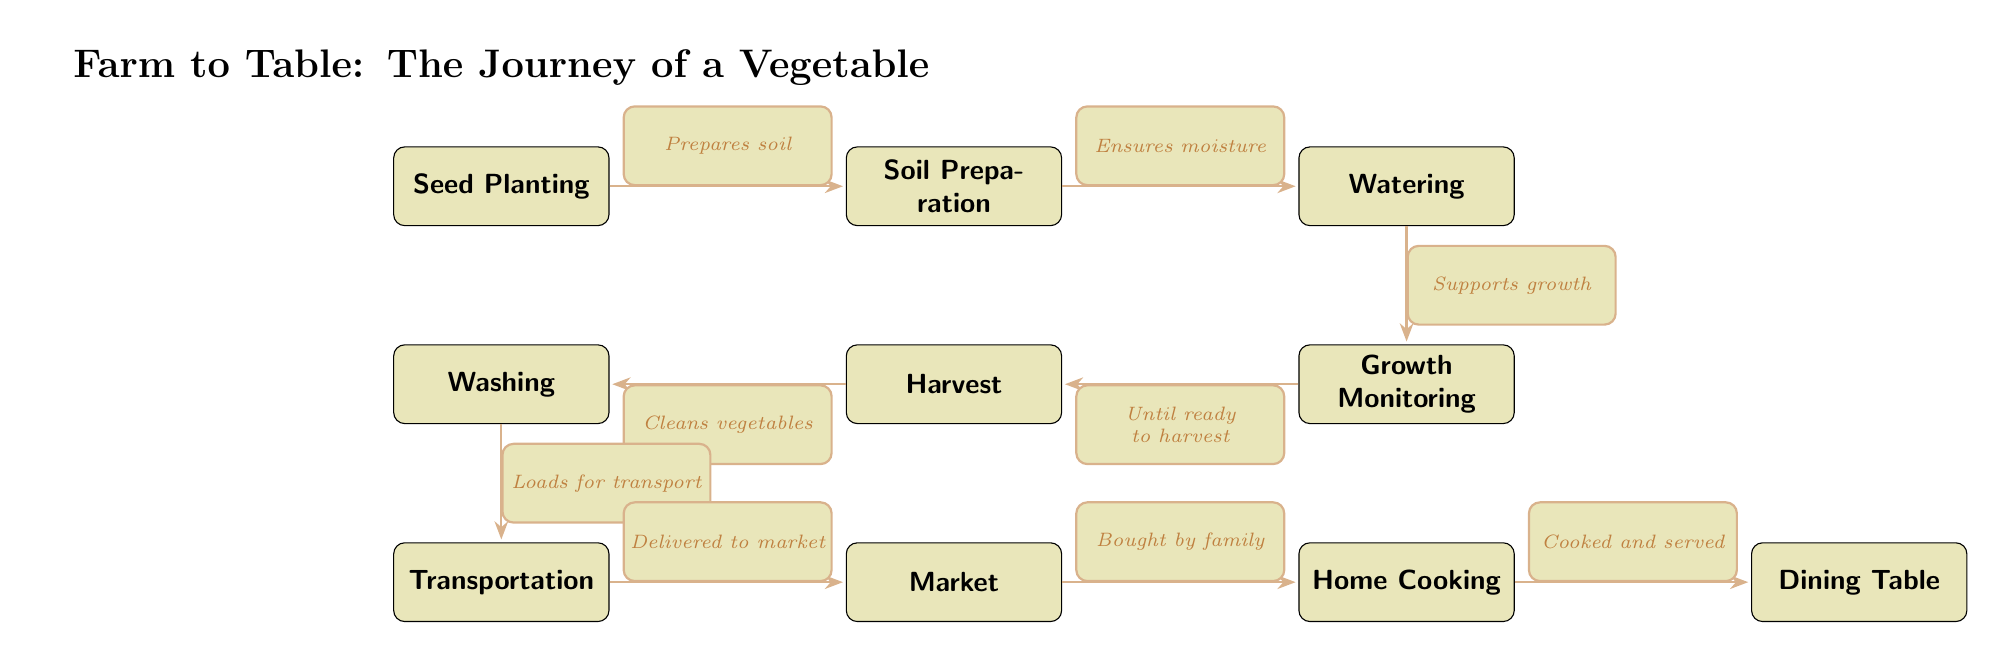What is the first step in the journey of a vegetable? The diagram begins with the node labeled "Seed Planting," indicating that this is the first action taken in the process.
Answer: Seed Planting How many main steps are there from seed planting to dining table? Counting the nodes in the diagram, there are a total of nine distinct steps from "Seed Planting" to "Dining Table."
Answer: Nine What does the "Washing" step involve? The edge leading from "Harvest" to "Washing" is labeled "Cleans vegetables," which describes the purpose of the washing step in the process.
Answer: Cleans vegetables Which step follows "Transportation"? The diagram shows that "Market" directly follows "Transportation," indicated by the arrow connecting the two nodes.
Answer: Market What is the relationship between "Growth Monitoring" and "Harvest"? The diagram shows an edge connecting "Growth Monitoring" to "Harvest," with the label stating "Until ready to harvest," indicating the timing relationship.
Answer: Until ready to harvest What occurs just before "Home Cooking"? The diagram connects "Market" to "Home Cooking," with the edge stating "Bought by family," which describes what must happen immediately before home cooking.
Answer: Bought by family How is water provided to the plants? The edge between "Soil Preparation" and "Watering" is labeled "Ensures moisture," which explains the role of watering in providing water to the plants.
Answer: Ensures moisture What is the last step in the journey of a vegetable? The diagram concludes with "Dining Table," showing it as the final step in the sequence of events leading from seed to the table.
Answer: Dining Table What is transported from washing to market? The edge from "Washing" to "Transportation" is labeled "Loads for transport," indicating that vegetables are transported after being washed.
Answer: Loads for transport 